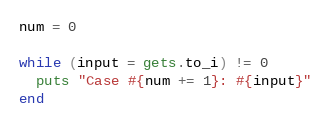<code> <loc_0><loc_0><loc_500><loc_500><_Ruby_>num = 0

while (input = gets.to_i) != 0
  puts "Case #{num += 1}: #{input}"
end</code> 